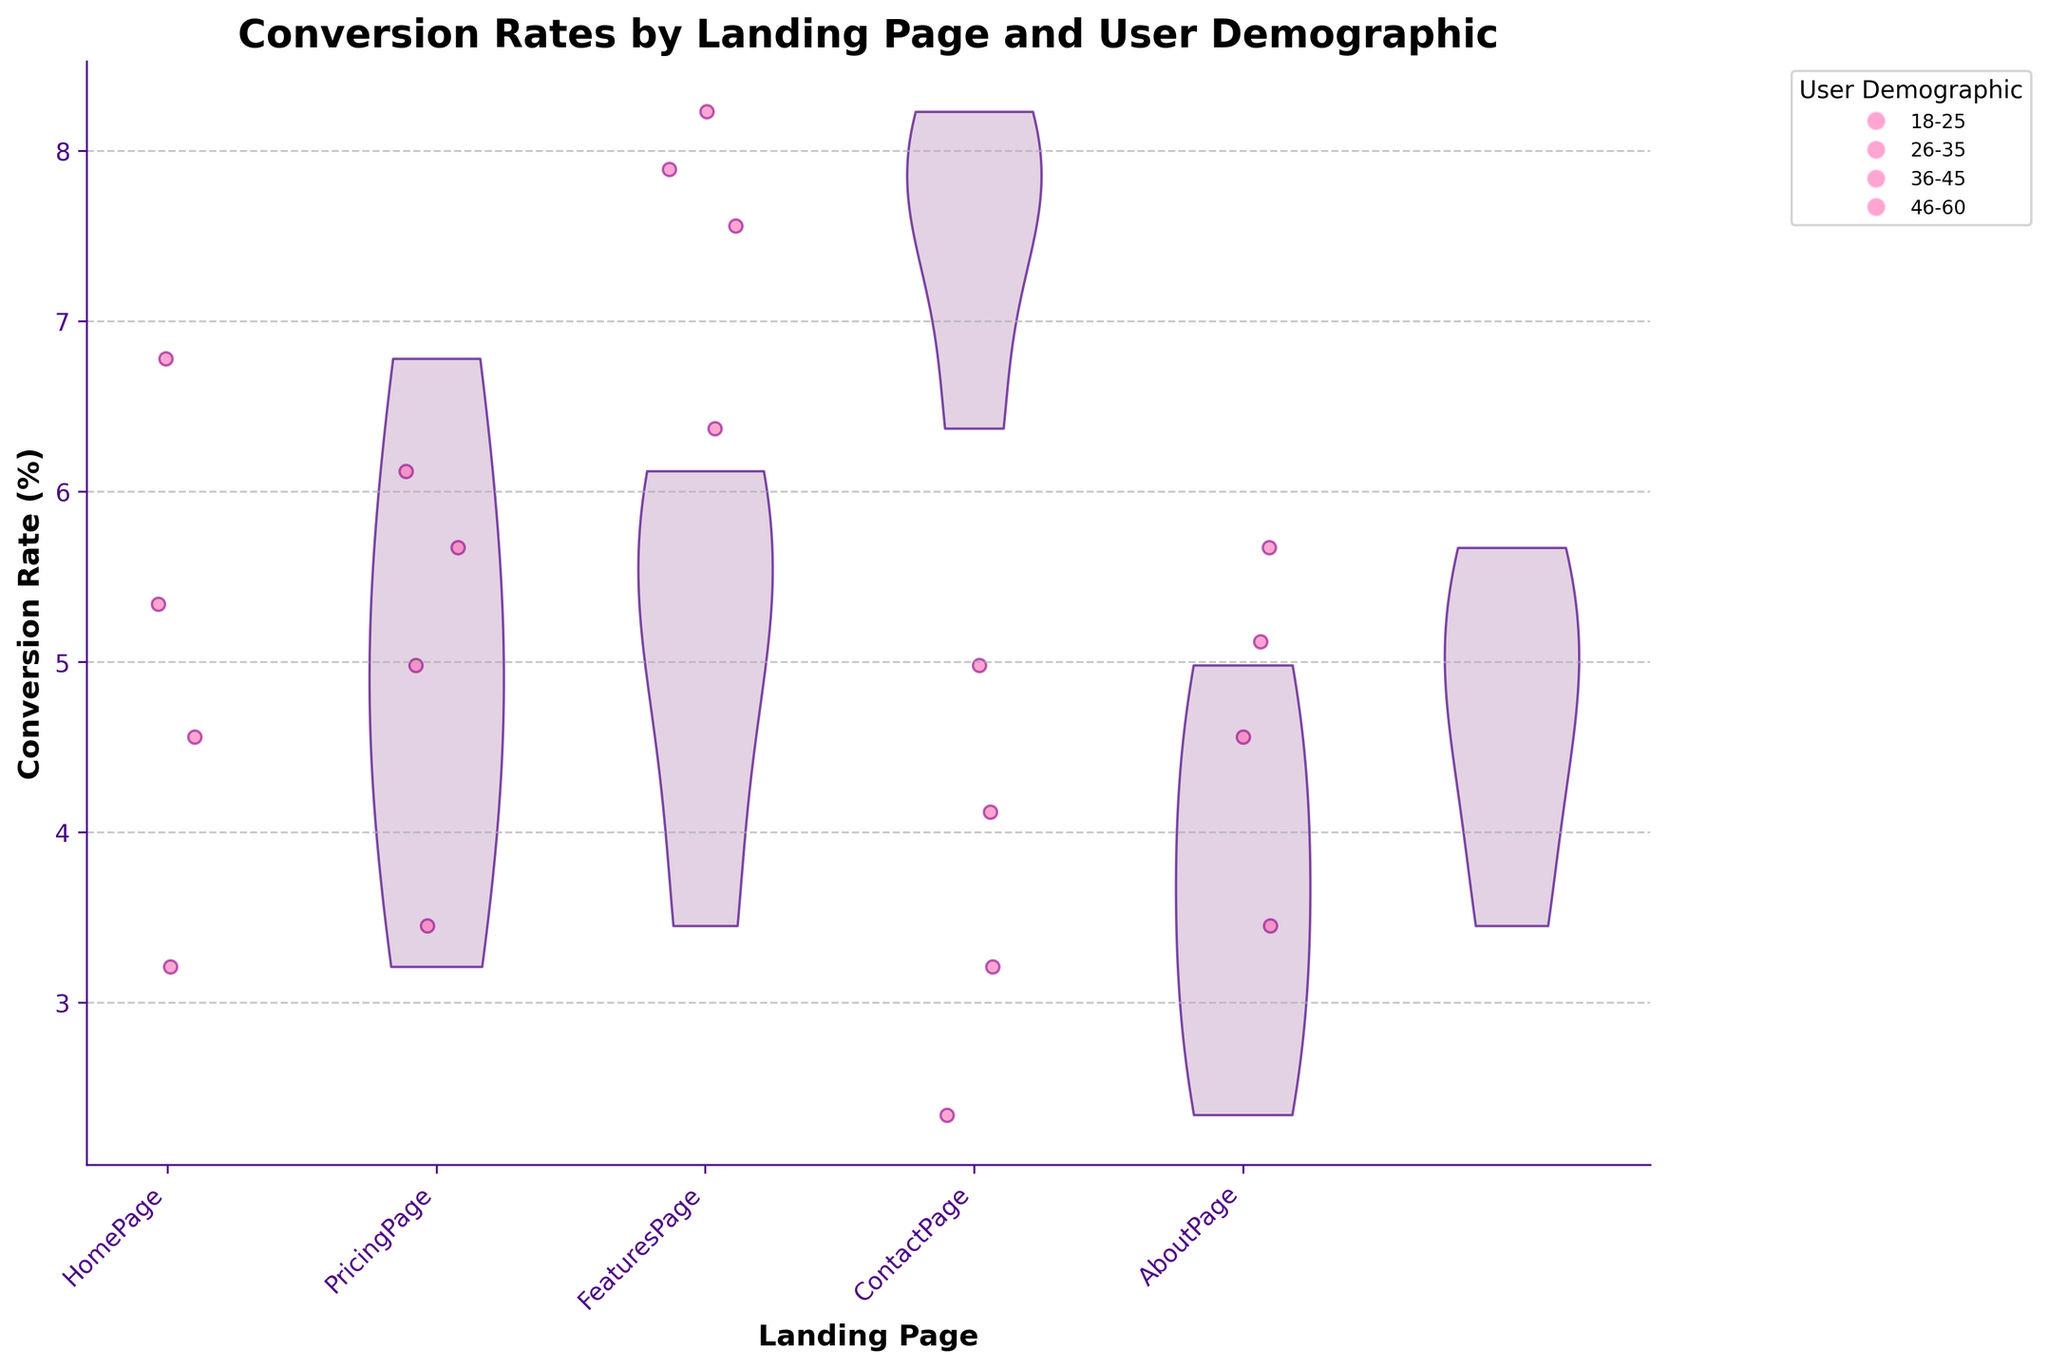What's the title of the figure? The title is typically provided at the top of the figure. In this case, it is "Conversion Rates by Landing Page and User Demographic".
Answer: Conversion Rates by Landing Page and User Demographic Which landing page has the highest overall conversion rate? By examining the violin plots, the FeaturesPage has the highest overall conversion rate, as it has the widest spread towards the higher values.
Answer: FeaturesPage What are the x-axis and y-axis labels? The labels for the x-axis and y-axis are usually displayed near the axes. Here, the x-axis label is "Landing Page", and the y-axis label is "Conversion Rate (%)".
Answer: Landing Page; Conversion Rate (%) How are user demographics represented in the figure? The user demographics are indicated by different jittered points scattered across the violin plots. Each colored jittered point corresponds to a specific user demographic group.
Answer: By different colored jittered points Which landing page has the lowest conversion rates for users aged 18-25? Observing the jittered points for the 18-25 demographic, the ContactPage has the lowest conversion rates as the points are clustered at the lower end of the conversion rate scale.
Answer: ContactPage What is the approximate conversion rate range for the PricingPage for users aged 36-45? The spread of the jittered points for the 36-45 demographic on the PricingPage violin plot shows their conversion rates range approximately from 5% to 7%.
Answer: 5% to 7% Which user demographic showed the highest conversion rates for the HomePage? Checking the jittered points on the HomePage violin plot, users aged 26-35 have the highest conversion rates as they are located at the higher end of the conversion rate values.
Answer: 26-35 Compare the conversion rates between the HomePage and AboutPage for users aged 26-35. Which is higher? By looking at the jittered points for the 26-35 demographic, it's clear that the HomePage has higher conversion rates as the points are higher on the y-axis compared to those on the AboutPage.
Answer: HomePage What is the general trend in conversion rates across landing pages for users aged 46-60? The jittered points for users aged 46-60 indicate a trend where the FeaturesPage has the highest conversion rates, followed by PricingPage, and the ContactPage shows the lowest rates.
Answer: FeaturesPage > PricingPage > ContactPage What does the color and transparency of the 'bodies' in the violin plot represent? The 'bodies' of the violin plots are colored to visually represent the distribution of the conversion rates for each landing page. Their transparency helps to distinguish overlapping areas and see the underlying scatter points.
Answer: Distribution of conversion rates 